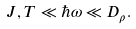Convert formula to latex. <formula><loc_0><loc_0><loc_500><loc_500>J , T \ll \hbar { \omega } \ll D _ { \rho } .</formula> 